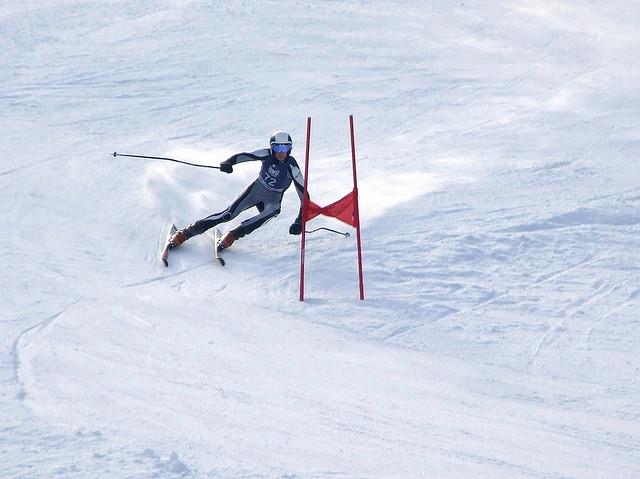Which way is the person leaning?
Concise answer only. Left. What color are the markers?
Keep it brief. Red. What color are the skier's skis?
Give a very brief answer. White. How many people are on the snow?
Give a very brief answer. 1. Is the player skiing?
Keep it brief. Yes. What color are flags?
Concise answer only. Red. Is the person going to hit the obstacle?
Keep it brief. Yes. What are the people going around?
Keep it brief. Poles. 